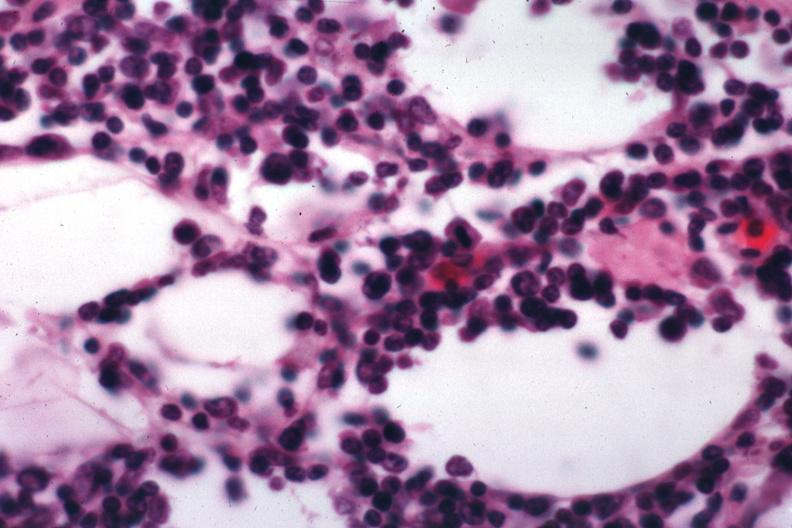what is present?
Answer the question using a single word or phrase. Lymph node 